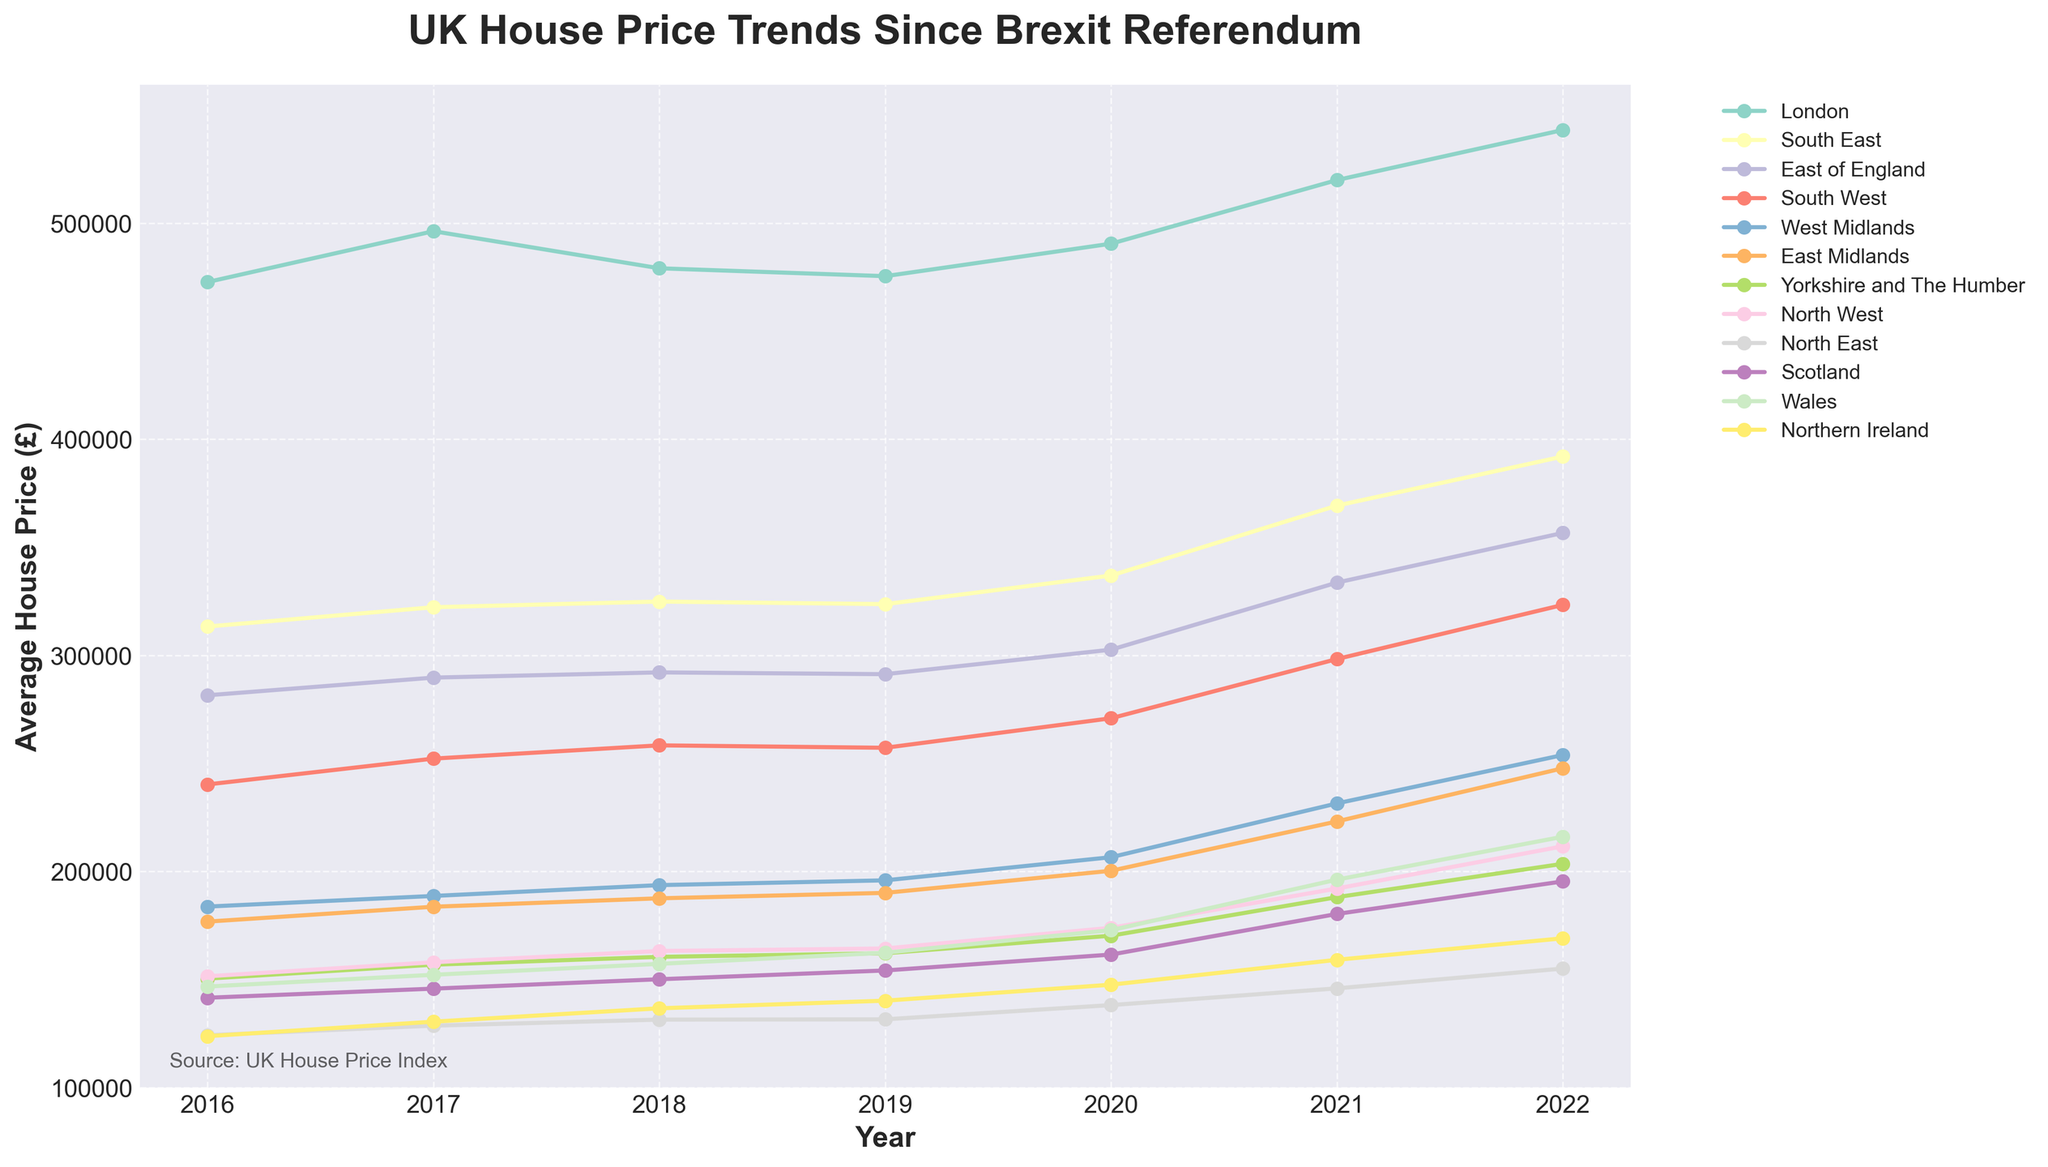What year did London see the biggest increase in average house price from the previous year? Look at the line for London and identify the year-to-year changes in values. The biggest increase is from 2020 to 2021, where the price increased from 490,495 to 519,934.
Answer: 2021 Which region experienced the smallest increase in average house price from 2016 to 2022? Calculate the difference in average house prices between 2016 and 2022 for all regions. The smallest increase is in the North East, which increased from 124,208 to 155,058.
Answer: North East By how much did the average price in the South West change between 2017 and 2019? Find the prices for the South West in 2017 and 2019. The change is 257,217 - 252,213 = 5,004.
Answer: 5,004 Which two regions had a crossover point in their average house prices, and in which year did this happen? Look for points where one line crosses another. The West Midlands and East Midlands had a crossover around 2017.
Answer: West Midlands and East Midlands, 2017 What is the trend of house prices in Northern Ireland since the start of the timeline? Follow the line for Northern Ireland from 2016 to 2022. The trend shows a steady increase in prices.
Answer: Steady increase What's the average house price of Yorkshire and The Humber over the entire period? Add the house prices for Yorkshire and The Humber for each year from 2016 to 2022, then divide by the number of years (7). The prices are 150,401, 156,848, 160,471, 162,129, 170,270, 188,097, 203,538. Sum is 1,192,754. 1,192,754 / 7 = 170,393.
Answer: 170,393 How does the price growth in Wales from 2019 to 2022 compare to that in Scotland for the same period? Compute the change for both regions between 2019 and 2022. Wales: 216,071 - 162,374 = 53,697. Scotland: 195,391 - 154,170 = 41,221. Wales had a greater increase.
Answer: Wales had a greater increase Which region had the highest house prices throughout the entire dataset? Track all the price points across the years for each region and find the consistently highest ones. London has the highest prices each year.
Answer: London Which two regions had the least and most volatile house price changes respectively? Volatility can be assessed by examining the magnitude of fluctuations in the data. The North East had the least volatility, and London had the most.
Answer: North East, London 